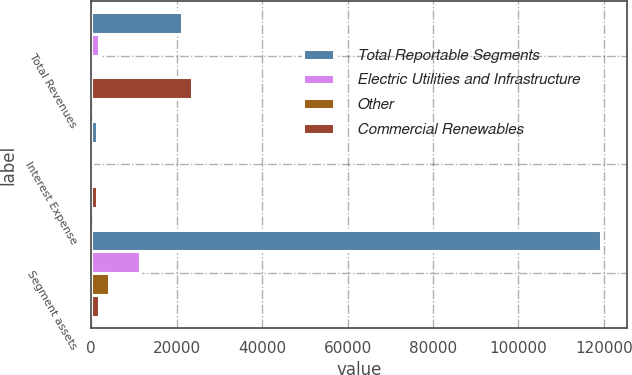Convert chart to OTSL. <chart><loc_0><loc_0><loc_500><loc_500><stacked_bar_chart><ecel><fcel>Total Revenues<fcel>Interest Expense<fcel>Segment assets<nl><fcel>Total Reportable Segments<fcel>21331<fcel>1240<fcel>119423<nl><fcel>Electric Utilities and Infrastructure<fcel>1836<fcel>105<fcel>11462<nl><fcel>Other<fcel>460<fcel>87<fcel>4156<nl><fcel>Commercial Renewables<fcel>23627<fcel>1432<fcel>1836<nl></chart> 